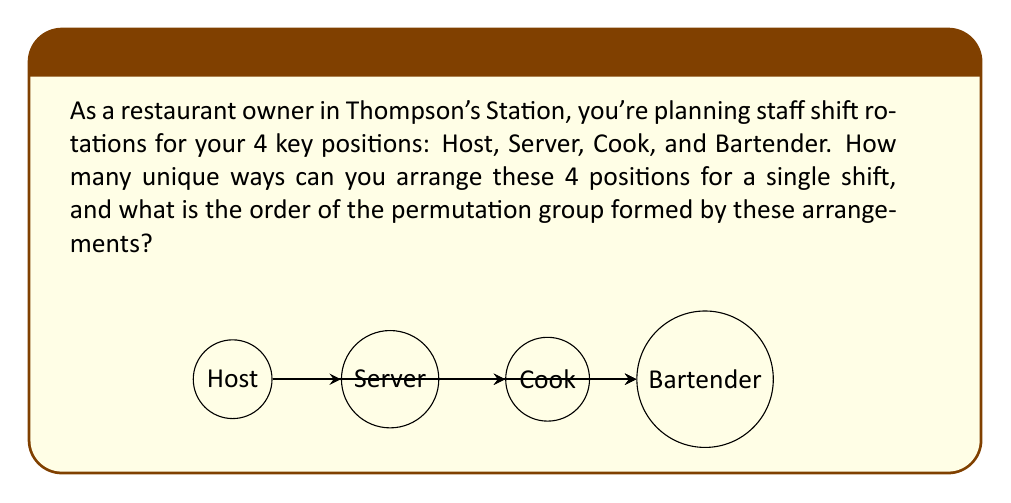Can you answer this question? Let's approach this step-by-step:

1) First, we need to understand what we're dealing with. We have 4 distinct positions that need to be arranged in a specific order for each shift.

2) This is a perfect scenario for using permutations. The number of permutations of n distinct objects is given by n!.

3) In this case, n = 4 (Host, Server, Cook, Bartender).

4) So, the number of unique arrangements is:

   $$4! = 4 \times 3 \times 2 \times 1 = 24$$

5) Now, let's consider the permutation group. Each arrangement can be thought of as a permutation of the initial arrangement (Host, Server, Cook, Bartender).

6) The set of all these permutations forms a group under the operation of composition. This group is known as the symmetric group on 4 elements, often denoted as $S_4$.

7) The order of a group is the number of elements in the group. In this case, it's the same as the number of permutations we calculated earlier.

8) Therefore, the order of the permutation group is also 24.

This means that there are 24 unique ways to arrange the staff positions, and the permutation group formed by these arrangements has an order of 24.
Answer: 24 